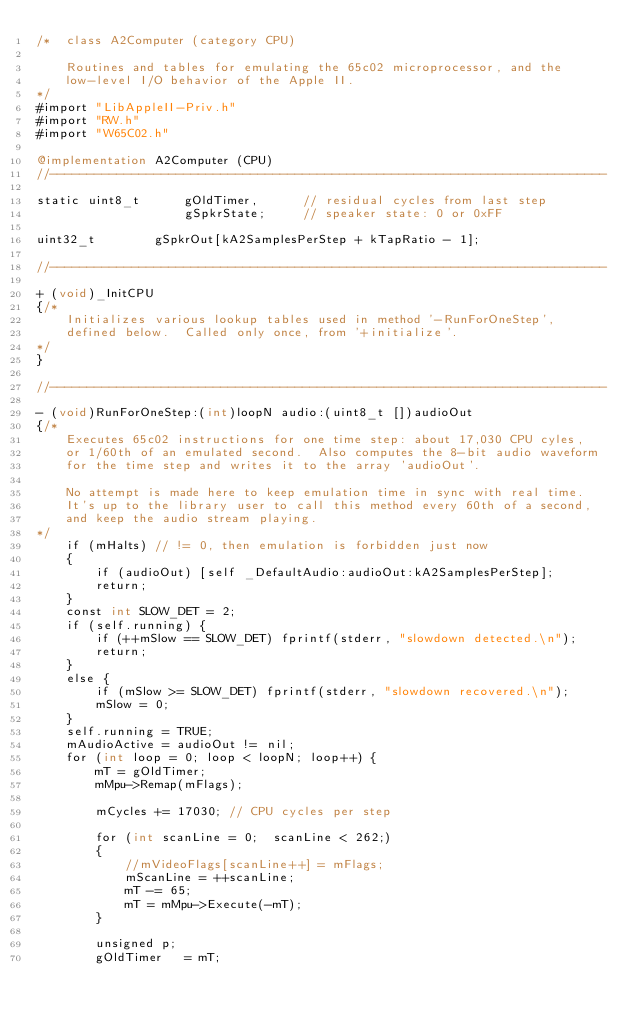<code> <loc_0><loc_0><loc_500><loc_500><_ObjectiveC_>/*	class A2Computer (category CPU)

	Routines and tables for emulating the 65c02 microprocessor, and the
	low-level I/O behavior of the Apple II.
*/
#import "LibAppleII-Priv.h"
#import "RW.h"
#import "W65C02.h"

@implementation A2Computer (CPU)
//---------------------------------------------------------------------------

static uint8_t		gOldTimer,		// residual cycles from last step
					gSpkrState;		// speaker state: 0 or 0xFF

uint32_t		gSpkrOut[kA2SamplesPerStep + kTapRatio - 1];

//---------------------------------------------------------------------------

+ (void)_InitCPU
{/*
	Initializes various lookup tables used in method '-RunForOneStep',
	defined below.  Called only once, from '+initialize'.
*/
}

//---------------------------------------------------------------------------

- (void)RunForOneStep:(int)loopN audio:(uint8_t [])audioOut
{/*
	Executes 65c02 instructions for one time step: about 17,030 CPU cyles,
	or 1/60th of an emulated second.  Also computes the 8-bit audio waveform
	for the time step and writes it to the array 'audioOut'.

	No attempt is made here to keep emulation time in sync with real time.
	It's up to the library user to call this method every 60th of a second,
	and keep the audio stream playing.
*/
	if (mHalts) // != 0, then emulation is forbidden just now
	{
		if (audioOut) [self _DefaultAudio:audioOut:kA2SamplesPerStep];
		return;
	}
	const int SLOW_DET = 2;
	if (self.running) {
		if (++mSlow == SLOW_DET) fprintf(stderr, "slowdown detected.\n");
		return;
	}
	else {
		if (mSlow >= SLOW_DET) fprintf(stderr, "slowdown recovered.\n");
		mSlow = 0;
	}
	self.running = TRUE;
	mAudioActive = audioOut != nil;
	for (int loop = 0; loop < loopN; loop++) {
		mT = gOldTimer;
		mMpu->Remap(mFlags);

		mCycles += 17030; // CPU cycles per step

		for (int scanLine = 0;  scanLine < 262;)
		{
			//mVideoFlags[scanLine++] = mFlags;
			mScanLine = ++scanLine;
			mT -= 65;
			mT = mMpu->Execute(-mT);
		}

		unsigned p;
		gOldTimer	= mT;</code> 